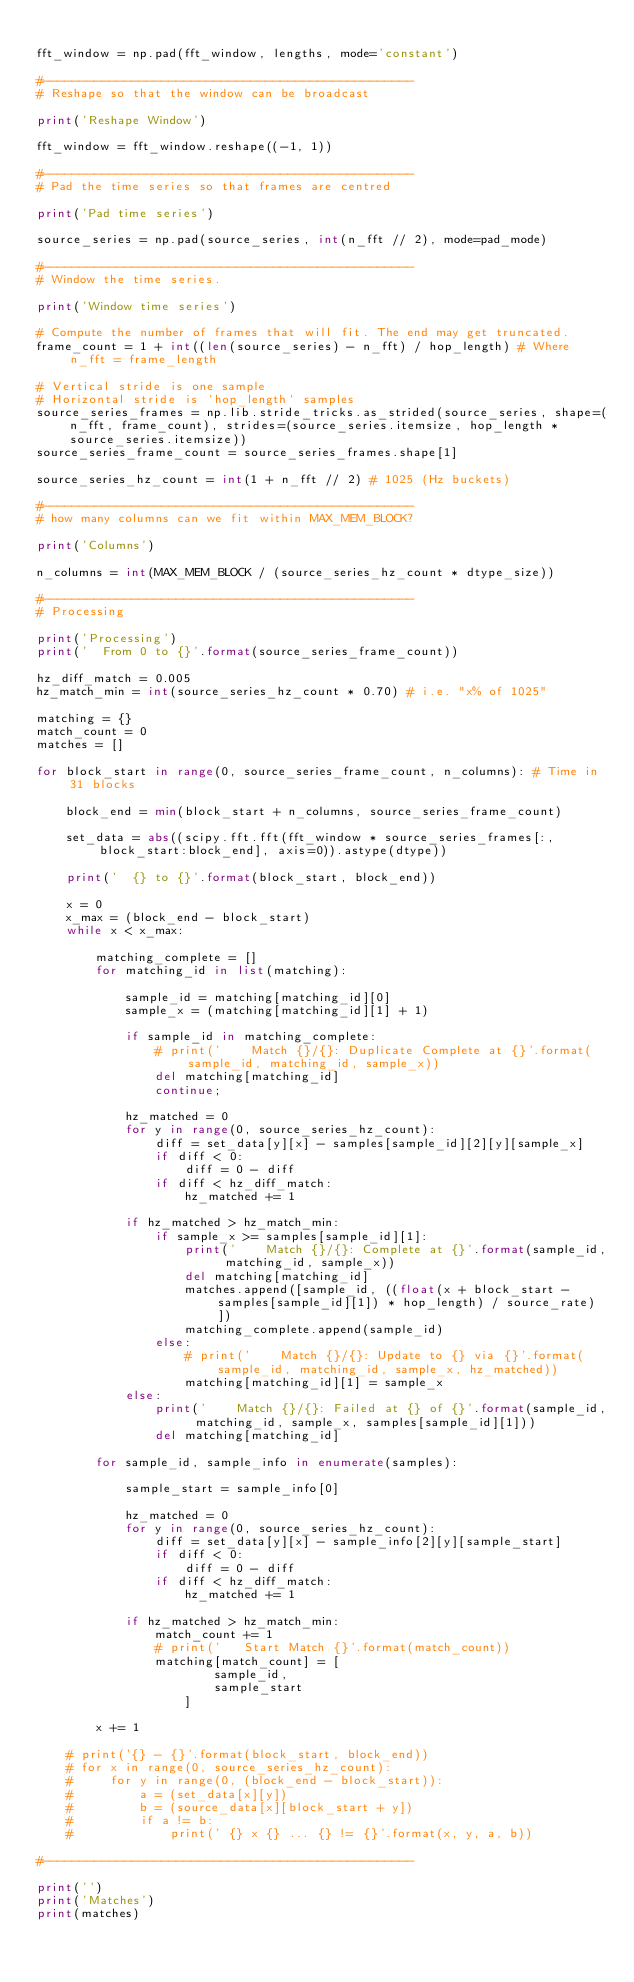<code> <loc_0><loc_0><loc_500><loc_500><_Python_>
fft_window = np.pad(fft_window, lengths, mode='constant')

#--------------------------------------------------
# Reshape so that the window can be broadcast

print('Reshape Window')

fft_window = fft_window.reshape((-1, 1))

#--------------------------------------------------
# Pad the time series so that frames are centred

print('Pad time series')

source_series = np.pad(source_series, int(n_fft // 2), mode=pad_mode)

#--------------------------------------------------
# Window the time series.

print('Window time series')

# Compute the number of frames that will fit. The end may get truncated.
frame_count = 1 + int((len(source_series) - n_fft) / hop_length) # Where n_fft = frame_length

# Vertical stride is one sample
# Horizontal stride is `hop_length` samples
source_series_frames = np.lib.stride_tricks.as_strided(source_series, shape=(n_fft, frame_count), strides=(source_series.itemsize, hop_length * source_series.itemsize))
source_series_frame_count = source_series_frames.shape[1]

source_series_hz_count = int(1 + n_fft // 2) # 1025 (Hz buckets)

#--------------------------------------------------
# how many columns can we fit within MAX_MEM_BLOCK?

print('Columns')

n_columns = int(MAX_MEM_BLOCK / (source_series_hz_count * dtype_size))

#--------------------------------------------------
# Processing

print('Processing')
print('  From 0 to {}'.format(source_series_frame_count))

hz_diff_match = 0.005
hz_match_min = int(source_series_hz_count * 0.70) # i.e. "x% of 1025"

matching = {}
match_count = 0
matches = []

for block_start in range(0, source_series_frame_count, n_columns): # Time in 31 blocks

    block_end = min(block_start + n_columns, source_series_frame_count)

    set_data = abs((scipy.fft.fft(fft_window * source_series_frames[:, block_start:block_end], axis=0)).astype(dtype))

    print('  {} to {}'.format(block_start, block_end))

    x = 0
    x_max = (block_end - block_start)
    while x < x_max:

        matching_complete = []
        for matching_id in list(matching):

            sample_id = matching[matching_id][0]
            sample_x = (matching[matching_id][1] + 1)

            if sample_id in matching_complete:
                # print('    Match {}/{}: Duplicate Complete at {}'.format(sample_id, matching_id, sample_x))
                del matching[matching_id]
                continue;

            hz_matched = 0
            for y in range(0, source_series_hz_count):
                diff = set_data[y][x] - samples[sample_id][2][y][sample_x]
                if diff < 0:
                    diff = 0 - diff
                if diff < hz_diff_match:
                    hz_matched += 1

            if hz_matched > hz_match_min:
                if sample_x >= samples[sample_id][1]:
                    print('    Match {}/{}: Complete at {}'.format(sample_id, matching_id, sample_x))
                    del matching[matching_id]
                    matches.append([sample_id, ((float(x + block_start - samples[sample_id][1]) * hop_length) / source_rate)])
                    matching_complete.append(sample_id)
                else:
                    # print('    Match {}/{}: Update to {} via {}'.format(sample_id, matching_id, sample_x, hz_matched))
                    matching[matching_id][1] = sample_x
            else:
                print('    Match {}/{}: Failed at {} of {}'.format(sample_id, matching_id, sample_x, samples[sample_id][1]))
                del matching[matching_id]

        for sample_id, sample_info in enumerate(samples):

            sample_start = sample_info[0]

            hz_matched = 0
            for y in range(0, source_series_hz_count):
                diff = set_data[y][x] - sample_info[2][y][sample_start]
                if diff < 0:
                    diff = 0 - diff
                if diff < hz_diff_match:
                    hz_matched += 1

            if hz_matched > hz_match_min:
                match_count += 1
                # print('   Start Match {}'.format(match_count))
                matching[match_count] = [
                        sample_id,
                        sample_start
                    ]

        x += 1

    # print('{} - {}'.format(block_start, block_end))
    # for x in range(0, source_series_hz_count):
    #     for y in range(0, (block_end - block_start)):
    #         a = (set_data[x][y])
    #         b = (source_data[x][block_start + y])
    #         if a != b:
    #             print(' {} x {} ... {} != {}'.format(x, y, a, b))

#--------------------------------------------------

print('')
print('Matches')
print(matches)
</code> 